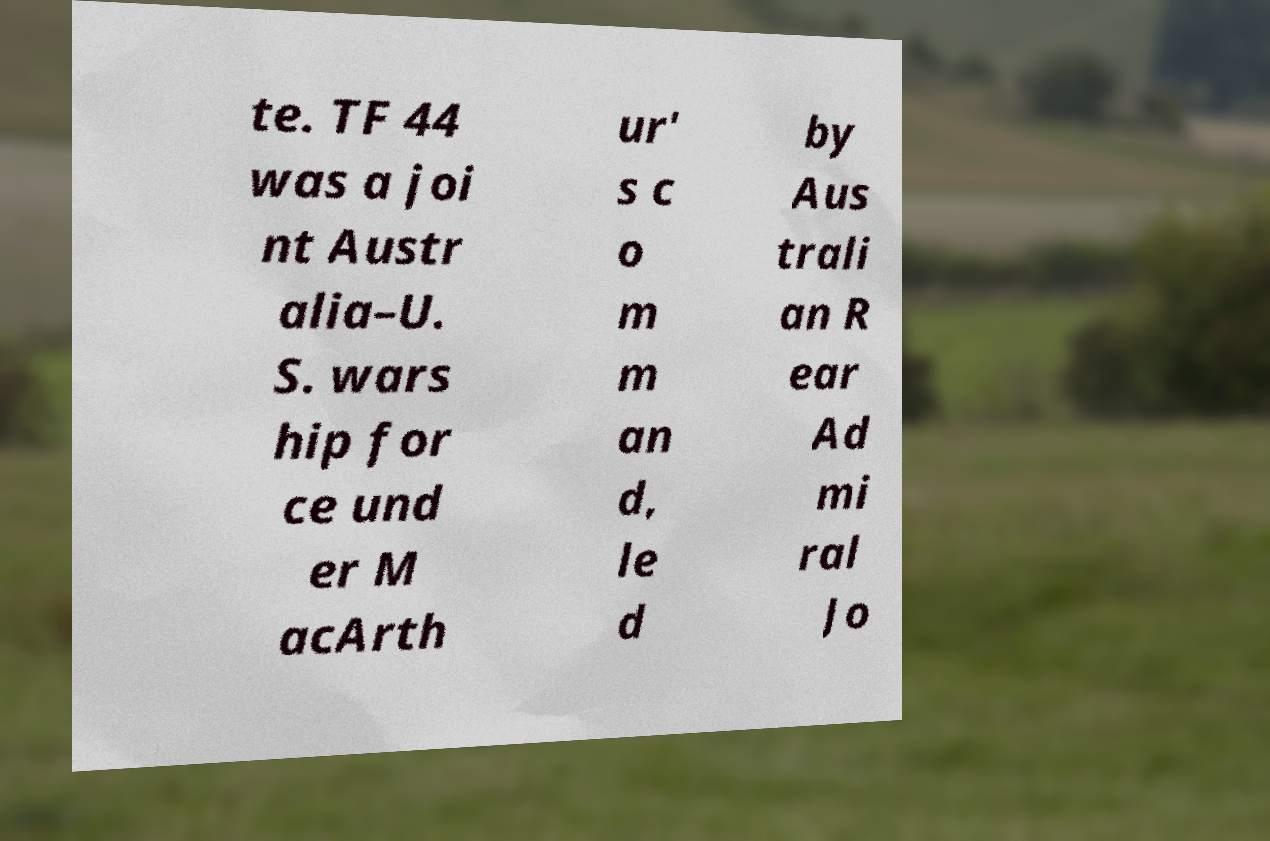Can you read and provide the text displayed in the image?This photo seems to have some interesting text. Can you extract and type it out for me? te. TF 44 was a joi nt Austr alia–U. S. wars hip for ce und er M acArth ur' s c o m m an d, le d by Aus trali an R ear Ad mi ral Jo 